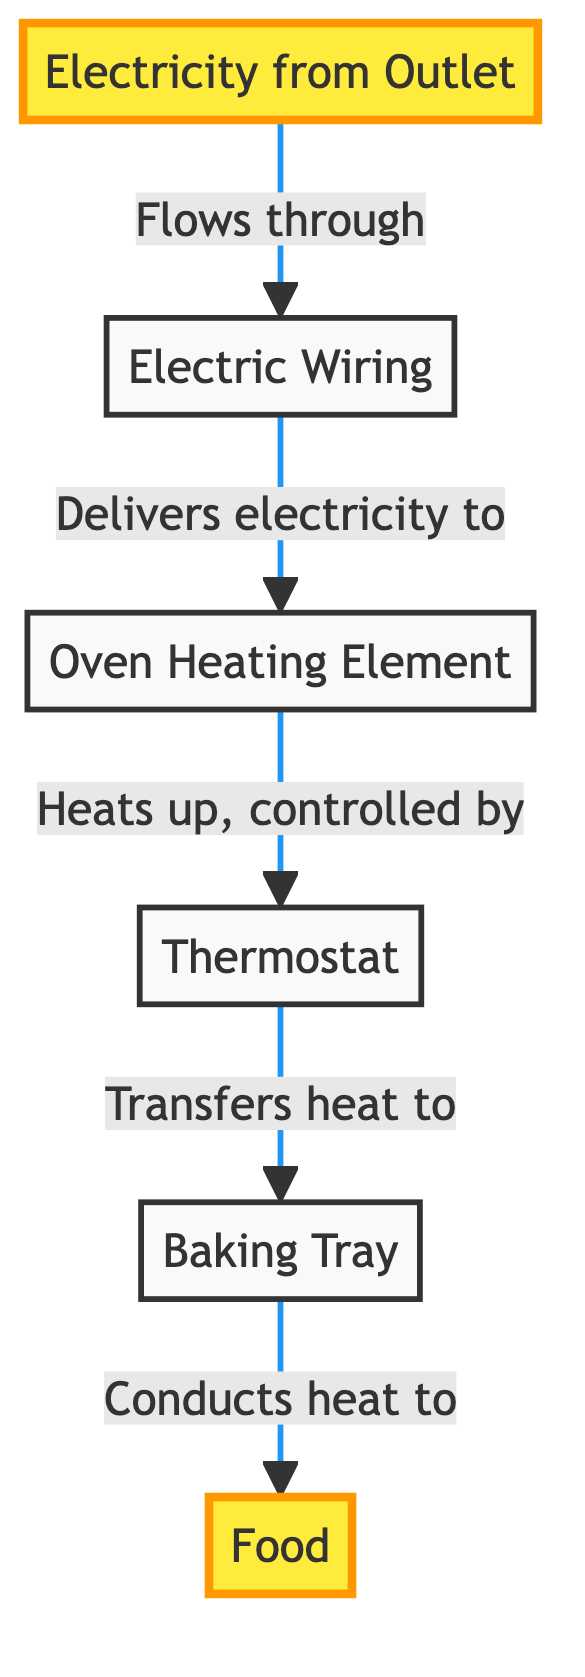What is the first element in the energy flow? The diagram indicates that the first element in the energy flow is "Electricity from Outlet," which is the starting point of the entire process.
Answer: Electricity from Outlet How many nodes are in the diagram? The diagram lists a total of six nodes: Electricity from Outlet, Electric Wiring, Oven Heating Element, Thermostat, Baking Tray, and Food. Therefore, the count of nodes is six.
Answer: 6 What does the electric wiring do? According to the diagram, the electric wiring’s role is to deliver electricity to the oven heating element, making it crucial for the energy transformation process.
Answer: Delivers electricity to What are the final two objects in the energy flow? The final two objects in the flow are the Baking Tray and Food, which receive the heat necessary for the baking process.
Answer: Baking Tray and Food How does heat transfer to the food? The diagram shows that heat is transferred to the food through the baking tray, which conducts the heat generated by the oven heating element, demonstrating the importance of this intermediary step.
Answer: Conducts heat to What controls the temperature of the oven? The diagram specifies that the thermostat controls the heating element, thereby regulating the temperature of the oven, which is essential for precise baking outcomes.
Answer: Thermostat What element directly heats up from electricity? The oven heating element directly heats up from the electricity that flows through the electric wiring, acting as the main source of heat for baking.
Answer: Oven Heating Element Which component follows the oven heating element in the flow? After the oven heating element, the next component in the flow is the thermostat, which plays a pivotal role in managing the heating process.
Answer: Thermostat How does the heating element get electricity? Electricity enters through the outlet, flows through the electric wiring, and then it delivers this electricity to the oven heating element, facilitating the energy conversion needed for baking.
Answer: Flows through electric wiring 